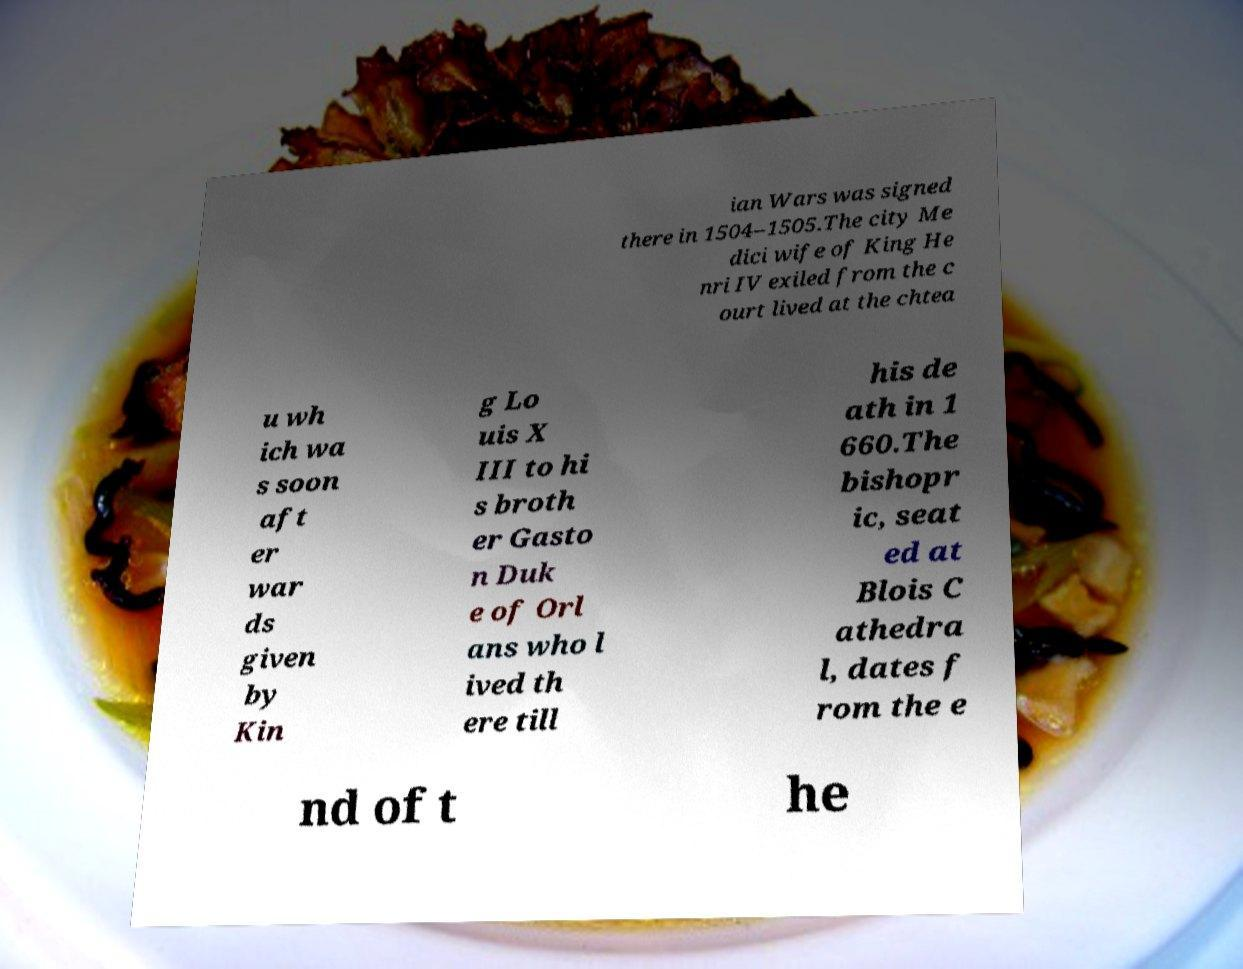Can you read and provide the text displayed in the image?This photo seems to have some interesting text. Can you extract and type it out for me? ian Wars was signed there in 1504–1505.The city Me dici wife of King He nri IV exiled from the c ourt lived at the chtea u wh ich wa s soon aft er war ds given by Kin g Lo uis X III to hi s broth er Gasto n Duk e of Orl ans who l ived th ere till his de ath in 1 660.The bishopr ic, seat ed at Blois C athedra l, dates f rom the e nd of t he 